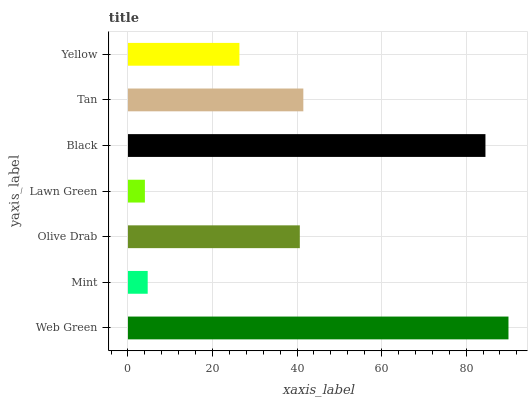Is Lawn Green the minimum?
Answer yes or no. Yes. Is Web Green the maximum?
Answer yes or no. Yes. Is Mint the minimum?
Answer yes or no. No. Is Mint the maximum?
Answer yes or no. No. Is Web Green greater than Mint?
Answer yes or no. Yes. Is Mint less than Web Green?
Answer yes or no. Yes. Is Mint greater than Web Green?
Answer yes or no. No. Is Web Green less than Mint?
Answer yes or no. No. Is Olive Drab the high median?
Answer yes or no. Yes. Is Olive Drab the low median?
Answer yes or no. Yes. Is Lawn Green the high median?
Answer yes or no. No. Is Yellow the low median?
Answer yes or no. No. 